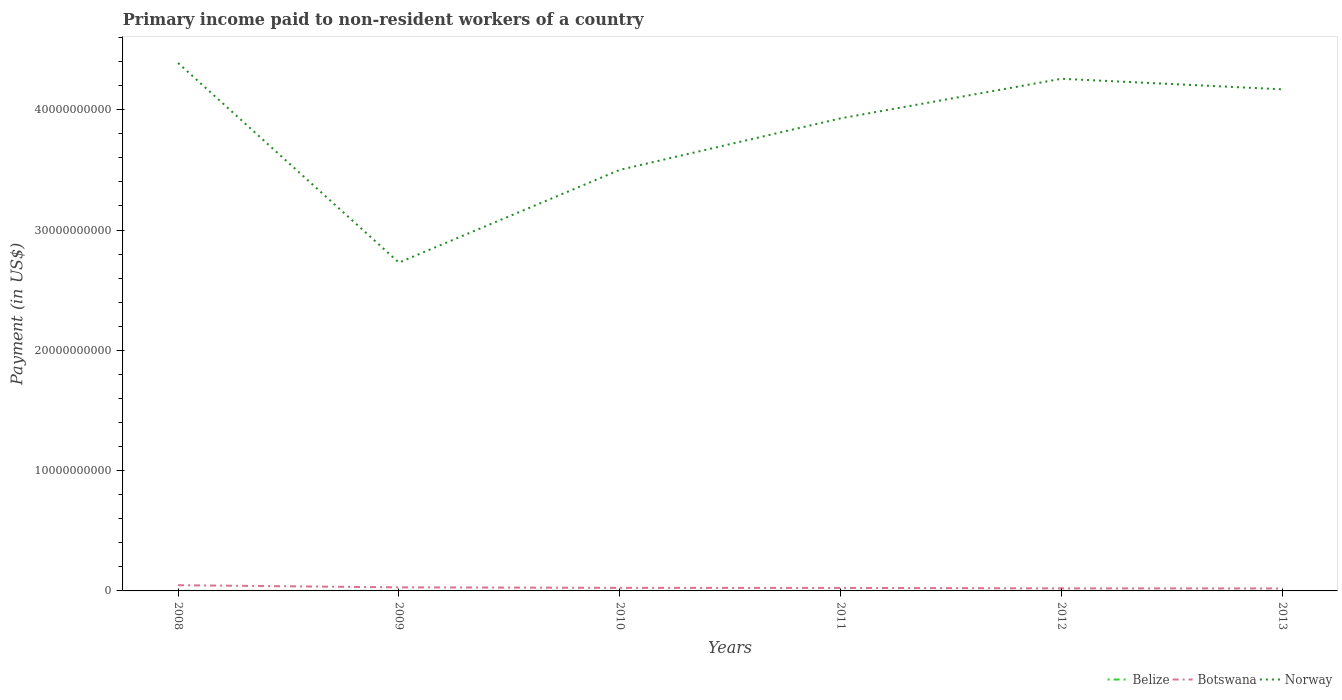How many different coloured lines are there?
Keep it short and to the point. 3. Does the line corresponding to Botswana intersect with the line corresponding to Belize?
Your answer should be compact. No. Is the number of lines equal to the number of legend labels?
Keep it short and to the point. Yes. Across all years, what is the maximum amount paid to workers in Belize?
Your answer should be compact. 4.47e+06. In which year was the amount paid to workers in Belize maximum?
Ensure brevity in your answer.  2009. What is the total amount paid to workers in Norway in the graph?
Your response must be concise. -1.53e+1. What is the difference between the highest and the second highest amount paid to workers in Botswana?
Your answer should be compact. 2.68e+08. Is the amount paid to workers in Belize strictly greater than the amount paid to workers in Botswana over the years?
Provide a succinct answer. Yes. How many lines are there?
Offer a terse response. 3. Are the values on the major ticks of Y-axis written in scientific E-notation?
Provide a succinct answer. No. Does the graph contain any zero values?
Your answer should be very brief. No. Where does the legend appear in the graph?
Your response must be concise. Bottom right. How are the legend labels stacked?
Your response must be concise. Horizontal. What is the title of the graph?
Keep it short and to the point. Primary income paid to non-resident workers of a country. Does "Tanzania" appear as one of the legend labels in the graph?
Provide a succinct answer. No. What is the label or title of the X-axis?
Provide a succinct answer. Years. What is the label or title of the Y-axis?
Give a very brief answer. Payment (in US$). What is the Payment (in US$) in Belize in 2008?
Your answer should be very brief. 5.93e+06. What is the Payment (in US$) in Botswana in 2008?
Give a very brief answer. 4.75e+08. What is the Payment (in US$) in Norway in 2008?
Keep it short and to the point. 4.39e+1. What is the Payment (in US$) of Belize in 2009?
Keep it short and to the point. 4.47e+06. What is the Payment (in US$) of Botswana in 2009?
Your answer should be very brief. 2.97e+08. What is the Payment (in US$) of Norway in 2009?
Offer a very short reply. 2.73e+1. What is the Payment (in US$) in Belize in 2010?
Offer a terse response. 4.59e+06. What is the Payment (in US$) in Botswana in 2010?
Provide a short and direct response. 2.56e+08. What is the Payment (in US$) in Norway in 2010?
Provide a short and direct response. 3.50e+1. What is the Payment (in US$) of Belize in 2011?
Provide a succinct answer. 4.76e+06. What is the Payment (in US$) of Botswana in 2011?
Provide a short and direct response. 2.50e+08. What is the Payment (in US$) of Norway in 2011?
Your answer should be compact. 3.93e+1. What is the Payment (in US$) in Belize in 2012?
Your response must be concise. 5.11e+06. What is the Payment (in US$) in Botswana in 2012?
Your answer should be very brief. 2.13e+08. What is the Payment (in US$) of Norway in 2012?
Provide a succinct answer. 4.26e+1. What is the Payment (in US$) in Belize in 2013?
Provide a succinct answer. 6.05e+06. What is the Payment (in US$) of Botswana in 2013?
Keep it short and to the point. 2.07e+08. What is the Payment (in US$) in Norway in 2013?
Offer a terse response. 4.17e+1. Across all years, what is the maximum Payment (in US$) of Belize?
Offer a very short reply. 6.05e+06. Across all years, what is the maximum Payment (in US$) of Botswana?
Your response must be concise. 4.75e+08. Across all years, what is the maximum Payment (in US$) in Norway?
Ensure brevity in your answer.  4.39e+1. Across all years, what is the minimum Payment (in US$) in Belize?
Your answer should be compact. 4.47e+06. Across all years, what is the minimum Payment (in US$) in Botswana?
Give a very brief answer. 2.07e+08. Across all years, what is the minimum Payment (in US$) of Norway?
Offer a terse response. 2.73e+1. What is the total Payment (in US$) of Belize in the graph?
Your answer should be compact. 3.09e+07. What is the total Payment (in US$) of Botswana in the graph?
Give a very brief answer. 1.70e+09. What is the total Payment (in US$) in Norway in the graph?
Give a very brief answer. 2.30e+11. What is the difference between the Payment (in US$) in Belize in 2008 and that in 2009?
Your response must be concise. 1.46e+06. What is the difference between the Payment (in US$) in Botswana in 2008 and that in 2009?
Provide a short and direct response. 1.78e+08. What is the difference between the Payment (in US$) of Norway in 2008 and that in 2009?
Offer a very short reply. 1.66e+1. What is the difference between the Payment (in US$) in Belize in 2008 and that in 2010?
Your response must be concise. 1.33e+06. What is the difference between the Payment (in US$) of Botswana in 2008 and that in 2010?
Ensure brevity in your answer.  2.19e+08. What is the difference between the Payment (in US$) in Norway in 2008 and that in 2010?
Offer a terse response. 8.88e+09. What is the difference between the Payment (in US$) of Belize in 2008 and that in 2011?
Provide a short and direct response. 1.16e+06. What is the difference between the Payment (in US$) in Botswana in 2008 and that in 2011?
Keep it short and to the point. 2.25e+08. What is the difference between the Payment (in US$) in Norway in 2008 and that in 2011?
Keep it short and to the point. 4.60e+09. What is the difference between the Payment (in US$) in Belize in 2008 and that in 2012?
Ensure brevity in your answer.  8.20e+05. What is the difference between the Payment (in US$) in Botswana in 2008 and that in 2012?
Keep it short and to the point. 2.62e+08. What is the difference between the Payment (in US$) of Norway in 2008 and that in 2012?
Your answer should be compact. 1.31e+09. What is the difference between the Payment (in US$) in Belize in 2008 and that in 2013?
Keep it short and to the point. -1.24e+05. What is the difference between the Payment (in US$) of Botswana in 2008 and that in 2013?
Your response must be concise. 2.68e+08. What is the difference between the Payment (in US$) of Norway in 2008 and that in 2013?
Ensure brevity in your answer.  2.19e+09. What is the difference between the Payment (in US$) in Belize in 2009 and that in 2010?
Offer a terse response. -1.27e+05. What is the difference between the Payment (in US$) in Botswana in 2009 and that in 2010?
Offer a terse response. 4.12e+07. What is the difference between the Payment (in US$) in Norway in 2009 and that in 2010?
Provide a succinct answer. -7.71e+09. What is the difference between the Payment (in US$) in Belize in 2009 and that in 2011?
Keep it short and to the point. -2.96e+05. What is the difference between the Payment (in US$) of Botswana in 2009 and that in 2011?
Offer a terse response. 4.72e+07. What is the difference between the Payment (in US$) in Norway in 2009 and that in 2011?
Offer a very short reply. -1.20e+1. What is the difference between the Payment (in US$) in Belize in 2009 and that in 2012?
Your response must be concise. -6.40e+05. What is the difference between the Payment (in US$) in Botswana in 2009 and that in 2012?
Ensure brevity in your answer.  8.40e+07. What is the difference between the Payment (in US$) in Norway in 2009 and that in 2012?
Your response must be concise. -1.53e+1. What is the difference between the Payment (in US$) of Belize in 2009 and that in 2013?
Provide a short and direct response. -1.58e+06. What is the difference between the Payment (in US$) in Botswana in 2009 and that in 2013?
Your answer should be compact. 9.02e+07. What is the difference between the Payment (in US$) in Norway in 2009 and that in 2013?
Give a very brief answer. -1.44e+1. What is the difference between the Payment (in US$) of Belize in 2010 and that in 2011?
Your answer should be compact. -1.68e+05. What is the difference between the Payment (in US$) in Botswana in 2010 and that in 2011?
Give a very brief answer. 5.99e+06. What is the difference between the Payment (in US$) of Norway in 2010 and that in 2011?
Provide a short and direct response. -4.28e+09. What is the difference between the Payment (in US$) in Belize in 2010 and that in 2012?
Give a very brief answer. -5.13e+05. What is the difference between the Payment (in US$) in Botswana in 2010 and that in 2012?
Your answer should be very brief. 4.29e+07. What is the difference between the Payment (in US$) in Norway in 2010 and that in 2012?
Give a very brief answer. -7.57e+09. What is the difference between the Payment (in US$) in Belize in 2010 and that in 2013?
Provide a short and direct response. -1.46e+06. What is the difference between the Payment (in US$) of Botswana in 2010 and that in 2013?
Keep it short and to the point. 4.90e+07. What is the difference between the Payment (in US$) in Norway in 2010 and that in 2013?
Offer a terse response. -6.69e+09. What is the difference between the Payment (in US$) of Belize in 2011 and that in 2012?
Keep it short and to the point. -3.44e+05. What is the difference between the Payment (in US$) in Botswana in 2011 and that in 2012?
Offer a very short reply. 3.69e+07. What is the difference between the Payment (in US$) of Norway in 2011 and that in 2012?
Your answer should be very brief. -3.29e+09. What is the difference between the Payment (in US$) of Belize in 2011 and that in 2013?
Provide a succinct answer. -1.29e+06. What is the difference between the Payment (in US$) of Botswana in 2011 and that in 2013?
Make the answer very short. 4.30e+07. What is the difference between the Payment (in US$) in Norway in 2011 and that in 2013?
Offer a very short reply. -2.41e+09. What is the difference between the Payment (in US$) in Belize in 2012 and that in 2013?
Offer a terse response. -9.43e+05. What is the difference between the Payment (in US$) of Botswana in 2012 and that in 2013?
Your response must be concise. 6.18e+06. What is the difference between the Payment (in US$) in Norway in 2012 and that in 2013?
Make the answer very short. 8.76e+08. What is the difference between the Payment (in US$) of Belize in 2008 and the Payment (in US$) of Botswana in 2009?
Your response must be concise. -2.91e+08. What is the difference between the Payment (in US$) of Belize in 2008 and the Payment (in US$) of Norway in 2009?
Make the answer very short. -2.73e+1. What is the difference between the Payment (in US$) in Botswana in 2008 and the Payment (in US$) in Norway in 2009?
Keep it short and to the point. -2.68e+1. What is the difference between the Payment (in US$) of Belize in 2008 and the Payment (in US$) of Botswana in 2010?
Your answer should be very brief. -2.50e+08. What is the difference between the Payment (in US$) in Belize in 2008 and the Payment (in US$) in Norway in 2010?
Provide a short and direct response. -3.50e+1. What is the difference between the Payment (in US$) of Botswana in 2008 and the Payment (in US$) of Norway in 2010?
Your response must be concise. -3.45e+1. What is the difference between the Payment (in US$) of Belize in 2008 and the Payment (in US$) of Botswana in 2011?
Keep it short and to the point. -2.44e+08. What is the difference between the Payment (in US$) in Belize in 2008 and the Payment (in US$) in Norway in 2011?
Provide a short and direct response. -3.93e+1. What is the difference between the Payment (in US$) of Botswana in 2008 and the Payment (in US$) of Norway in 2011?
Make the answer very short. -3.88e+1. What is the difference between the Payment (in US$) of Belize in 2008 and the Payment (in US$) of Botswana in 2012?
Provide a short and direct response. -2.07e+08. What is the difference between the Payment (in US$) in Belize in 2008 and the Payment (in US$) in Norway in 2012?
Give a very brief answer. -4.26e+1. What is the difference between the Payment (in US$) in Botswana in 2008 and the Payment (in US$) in Norway in 2012?
Your answer should be very brief. -4.21e+1. What is the difference between the Payment (in US$) of Belize in 2008 and the Payment (in US$) of Botswana in 2013?
Your answer should be compact. -2.01e+08. What is the difference between the Payment (in US$) of Belize in 2008 and the Payment (in US$) of Norway in 2013?
Your response must be concise. -4.17e+1. What is the difference between the Payment (in US$) in Botswana in 2008 and the Payment (in US$) in Norway in 2013?
Your answer should be very brief. -4.12e+1. What is the difference between the Payment (in US$) in Belize in 2009 and the Payment (in US$) in Botswana in 2010?
Your answer should be very brief. -2.51e+08. What is the difference between the Payment (in US$) of Belize in 2009 and the Payment (in US$) of Norway in 2010?
Provide a short and direct response. -3.50e+1. What is the difference between the Payment (in US$) of Botswana in 2009 and the Payment (in US$) of Norway in 2010?
Provide a succinct answer. -3.47e+1. What is the difference between the Payment (in US$) in Belize in 2009 and the Payment (in US$) in Botswana in 2011?
Provide a succinct answer. -2.45e+08. What is the difference between the Payment (in US$) of Belize in 2009 and the Payment (in US$) of Norway in 2011?
Give a very brief answer. -3.93e+1. What is the difference between the Payment (in US$) in Botswana in 2009 and the Payment (in US$) in Norway in 2011?
Your answer should be compact. -3.90e+1. What is the difference between the Payment (in US$) of Belize in 2009 and the Payment (in US$) of Botswana in 2012?
Ensure brevity in your answer.  -2.08e+08. What is the difference between the Payment (in US$) in Belize in 2009 and the Payment (in US$) in Norway in 2012?
Make the answer very short. -4.26e+1. What is the difference between the Payment (in US$) in Botswana in 2009 and the Payment (in US$) in Norway in 2012?
Keep it short and to the point. -4.23e+1. What is the difference between the Payment (in US$) in Belize in 2009 and the Payment (in US$) in Botswana in 2013?
Ensure brevity in your answer.  -2.02e+08. What is the difference between the Payment (in US$) in Belize in 2009 and the Payment (in US$) in Norway in 2013?
Offer a very short reply. -4.17e+1. What is the difference between the Payment (in US$) of Botswana in 2009 and the Payment (in US$) of Norway in 2013?
Provide a short and direct response. -4.14e+1. What is the difference between the Payment (in US$) in Belize in 2010 and the Payment (in US$) in Botswana in 2011?
Your answer should be very brief. -2.45e+08. What is the difference between the Payment (in US$) in Belize in 2010 and the Payment (in US$) in Norway in 2011?
Your answer should be compact. -3.93e+1. What is the difference between the Payment (in US$) in Botswana in 2010 and the Payment (in US$) in Norway in 2011?
Give a very brief answer. -3.90e+1. What is the difference between the Payment (in US$) in Belize in 2010 and the Payment (in US$) in Botswana in 2012?
Offer a terse response. -2.08e+08. What is the difference between the Payment (in US$) in Belize in 2010 and the Payment (in US$) in Norway in 2012?
Your answer should be very brief. -4.26e+1. What is the difference between the Payment (in US$) of Botswana in 2010 and the Payment (in US$) of Norway in 2012?
Make the answer very short. -4.23e+1. What is the difference between the Payment (in US$) of Belize in 2010 and the Payment (in US$) of Botswana in 2013?
Provide a short and direct response. -2.02e+08. What is the difference between the Payment (in US$) of Belize in 2010 and the Payment (in US$) of Norway in 2013?
Your answer should be compact. -4.17e+1. What is the difference between the Payment (in US$) of Botswana in 2010 and the Payment (in US$) of Norway in 2013?
Offer a terse response. -4.14e+1. What is the difference between the Payment (in US$) of Belize in 2011 and the Payment (in US$) of Botswana in 2012?
Your answer should be compact. -2.08e+08. What is the difference between the Payment (in US$) in Belize in 2011 and the Payment (in US$) in Norway in 2012?
Give a very brief answer. -4.26e+1. What is the difference between the Payment (in US$) of Botswana in 2011 and the Payment (in US$) of Norway in 2012?
Offer a terse response. -4.23e+1. What is the difference between the Payment (in US$) in Belize in 2011 and the Payment (in US$) in Botswana in 2013?
Provide a succinct answer. -2.02e+08. What is the difference between the Payment (in US$) of Belize in 2011 and the Payment (in US$) of Norway in 2013?
Provide a short and direct response. -4.17e+1. What is the difference between the Payment (in US$) in Botswana in 2011 and the Payment (in US$) in Norway in 2013?
Provide a succinct answer. -4.14e+1. What is the difference between the Payment (in US$) in Belize in 2012 and the Payment (in US$) in Botswana in 2013?
Ensure brevity in your answer.  -2.01e+08. What is the difference between the Payment (in US$) of Belize in 2012 and the Payment (in US$) of Norway in 2013?
Your answer should be compact. -4.17e+1. What is the difference between the Payment (in US$) in Botswana in 2012 and the Payment (in US$) in Norway in 2013?
Make the answer very short. -4.15e+1. What is the average Payment (in US$) in Belize per year?
Keep it short and to the point. 5.15e+06. What is the average Payment (in US$) of Botswana per year?
Your answer should be compact. 2.83e+08. What is the average Payment (in US$) of Norway per year?
Your answer should be very brief. 3.83e+1. In the year 2008, what is the difference between the Payment (in US$) of Belize and Payment (in US$) of Botswana?
Make the answer very short. -4.69e+08. In the year 2008, what is the difference between the Payment (in US$) of Belize and Payment (in US$) of Norway?
Your answer should be very brief. -4.39e+1. In the year 2008, what is the difference between the Payment (in US$) in Botswana and Payment (in US$) in Norway?
Offer a very short reply. -4.34e+1. In the year 2009, what is the difference between the Payment (in US$) in Belize and Payment (in US$) in Botswana?
Ensure brevity in your answer.  -2.92e+08. In the year 2009, what is the difference between the Payment (in US$) in Belize and Payment (in US$) in Norway?
Your answer should be compact. -2.73e+1. In the year 2009, what is the difference between the Payment (in US$) of Botswana and Payment (in US$) of Norway?
Make the answer very short. -2.70e+1. In the year 2010, what is the difference between the Payment (in US$) of Belize and Payment (in US$) of Botswana?
Your answer should be compact. -2.51e+08. In the year 2010, what is the difference between the Payment (in US$) in Belize and Payment (in US$) in Norway?
Offer a terse response. -3.50e+1. In the year 2010, what is the difference between the Payment (in US$) in Botswana and Payment (in US$) in Norway?
Provide a succinct answer. -3.47e+1. In the year 2011, what is the difference between the Payment (in US$) of Belize and Payment (in US$) of Botswana?
Keep it short and to the point. -2.45e+08. In the year 2011, what is the difference between the Payment (in US$) in Belize and Payment (in US$) in Norway?
Your answer should be compact. -3.93e+1. In the year 2011, what is the difference between the Payment (in US$) in Botswana and Payment (in US$) in Norway?
Give a very brief answer. -3.90e+1. In the year 2012, what is the difference between the Payment (in US$) of Belize and Payment (in US$) of Botswana?
Provide a succinct answer. -2.08e+08. In the year 2012, what is the difference between the Payment (in US$) in Belize and Payment (in US$) in Norway?
Keep it short and to the point. -4.26e+1. In the year 2012, what is the difference between the Payment (in US$) in Botswana and Payment (in US$) in Norway?
Give a very brief answer. -4.24e+1. In the year 2013, what is the difference between the Payment (in US$) in Belize and Payment (in US$) in Botswana?
Offer a very short reply. -2.00e+08. In the year 2013, what is the difference between the Payment (in US$) of Belize and Payment (in US$) of Norway?
Offer a terse response. -4.17e+1. In the year 2013, what is the difference between the Payment (in US$) in Botswana and Payment (in US$) in Norway?
Ensure brevity in your answer.  -4.15e+1. What is the ratio of the Payment (in US$) in Belize in 2008 to that in 2009?
Make the answer very short. 1.33. What is the ratio of the Payment (in US$) in Botswana in 2008 to that in 2009?
Your answer should be very brief. 1.6. What is the ratio of the Payment (in US$) of Norway in 2008 to that in 2009?
Your answer should be very brief. 1.61. What is the ratio of the Payment (in US$) of Belize in 2008 to that in 2010?
Your answer should be compact. 1.29. What is the ratio of the Payment (in US$) of Botswana in 2008 to that in 2010?
Give a very brief answer. 1.86. What is the ratio of the Payment (in US$) in Norway in 2008 to that in 2010?
Your answer should be very brief. 1.25. What is the ratio of the Payment (in US$) in Belize in 2008 to that in 2011?
Offer a terse response. 1.24. What is the ratio of the Payment (in US$) in Botswana in 2008 to that in 2011?
Your answer should be compact. 1.9. What is the ratio of the Payment (in US$) of Norway in 2008 to that in 2011?
Your response must be concise. 1.12. What is the ratio of the Payment (in US$) of Belize in 2008 to that in 2012?
Ensure brevity in your answer.  1.16. What is the ratio of the Payment (in US$) in Botswana in 2008 to that in 2012?
Keep it short and to the point. 2.23. What is the ratio of the Payment (in US$) in Norway in 2008 to that in 2012?
Provide a short and direct response. 1.03. What is the ratio of the Payment (in US$) in Belize in 2008 to that in 2013?
Make the answer very short. 0.98. What is the ratio of the Payment (in US$) in Botswana in 2008 to that in 2013?
Offer a very short reply. 2.3. What is the ratio of the Payment (in US$) of Norway in 2008 to that in 2013?
Your answer should be compact. 1.05. What is the ratio of the Payment (in US$) in Belize in 2009 to that in 2010?
Ensure brevity in your answer.  0.97. What is the ratio of the Payment (in US$) in Botswana in 2009 to that in 2010?
Your answer should be very brief. 1.16. What is the ratio of the Payment (in US$) of Norway in 2009 to that in 2010?
Your response must be concise. 0.78. What is the ratio of the Payment (in US$) in Belize in 2009 to that in 2011?
Keep it short and to the point. 0.94. What is the ratio of the Payment (in US$) in Botswana in 2009 to that in 2011?
Your response must be concise. 1.19. What is the ratio of the Payment (in US$) in Norway in 2009 to that in 2011?
Provide a succinct answer. 0.69. What is the ratio of the Payment (in US$) in Belize in 2009 to that in 2012?
Provide a succinct answer. 0.87. What is the ratio of the Payment (in US$) in Botswana in 2009 to that in 2012?
Offer a terse response. 1.4. What is the ratio of the Payment (in US$) in Norway in 2009 to that in 2012?
Your answer should be very brief. 0.64. What is the ratio of the Payment (in US$) in Belize in 2009 to that in 2013?
Your response must be concise. 0.74. What is the ratio of the Payment (in US$) in Botswana in 2009 to that in 2013?
Give a very brief answer. 1.44. What is the ratio of the Payment (in US$) in Norway in 2009 to that in 2013?
Your answer should be very brief. 0.65. What is the ratio of the Payment (in US$) of Belize in 2010 to that in 2011?
Provide a succinct answer. 0.96. What is the ratio of the Payment (in US$) of Norway in 2010 to that in 2011?
Your response must be concise. 0.89. What is the ratio of the Payment (in US$) in Belize in 2010 to that in 2012?
Provide a succinct answer. 0.9. What is the ratio of the Payment (in US$) of Botswana in 2010 to that in 2012?
Your answer should be compact. 1.2. What is the ratio of the Payment (in US$) in Norway in 2010 to that in 2012?
Offer a terse response. 0.82. What is the ratio of the Payment (in US$) of Belize in 2010 to that in 2013?
Provide a succinct answer. 0.76. What is the ratio of the Payment (in US$) of Botswana in 2010 to that in 2013?
Provide a short and direct response. 1.24. What is the ratio of the Payment (in US$) of Norway in 2010 to that in 2013?
Ensure brevity in your answer.  0.84. What is the ratio of the Payment (in US$) in Belize in 2011 to that in 2012?
Provide a short and direct response. 0.93. What is the ratio of the Payment (in US$) in Botswana in 2011 to that in 2012?
Offer a very short reply. 1.17. What is the ratio of the Payment (in US$) of Norway in 2011 to that in 2012?
Provide a short and direct response. 0.92. What is the ratio of the Payment (in US$) of Belize in 2011 to that in 2013?
Your response must be concise. 0.79. What is the ratio of the Payment (in US$) in Botswana in 2011 to that in 2013?
Offer a terse response. 1.21. What is the ratio of the Payment (in US$) of Norway in 2011 to that in 2013?
Ensure brevity in your answer.  0.94. What is the ratio of the Payment (in US$) of Belize in 2012 to that in 2013?
Offer a terse response. 0.84. What is the ratio of the Payment (in US$) in Botswana in 2012 to that in 2013?
Make the answer very short. 1.03. What is the difference between the highest and the second highest Payment (in US$) in Belize?
Provide a short and direct response. 1.24e+05. What is the difference between the highest and the second highest Payment (in US$) of Botswana?
Provide a succinct answer. 1.78e+08. What is the difference between the highest and the second highest Payment (in US$) of Norway?
Ensure brevity in your answer.  1.31e+09. What is the difference between the highest and the lowest Payment (in US$) of Belize?
Your answer should be very brief. 1.58e+06. What is the difference between the highest and the lowest Payment (in US$) of Botswana?
Your answer should be very brief. 2.68e+08. What is the difference between the highest and the lowest Payment (in US$) of Norway?
Provide a short and direct response. 1.66e+1. 